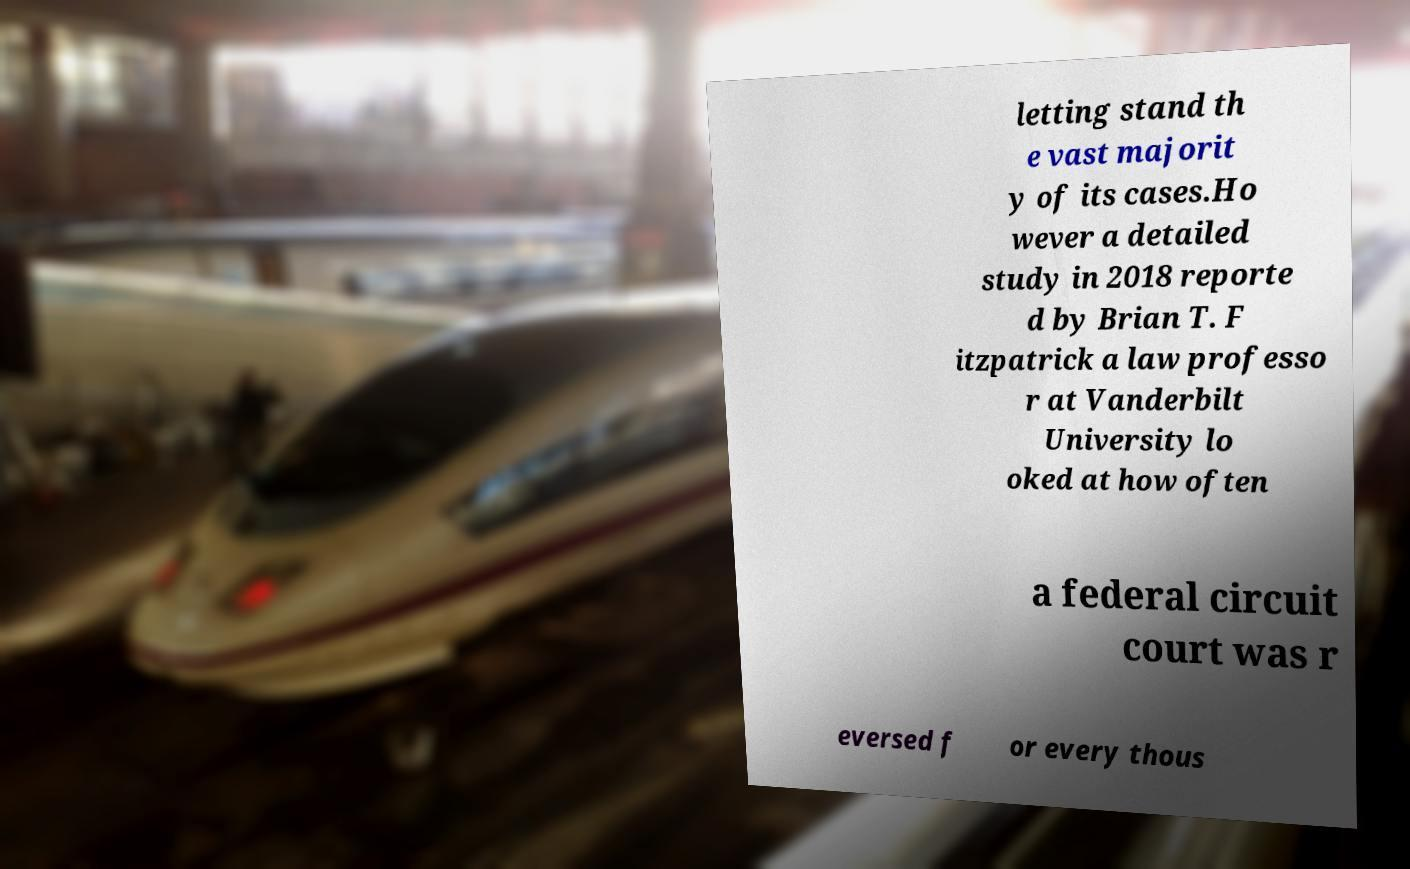Please identify and transcribe the text found in this image. letting stand th e vast majorit y of its cases.Ho wever a detailed study in 2018 reporte d by Brian T. F itzpatrick a law professo r at Vanderbilt University lo oked at how often a federal circuit court was r eversed f or every thous 